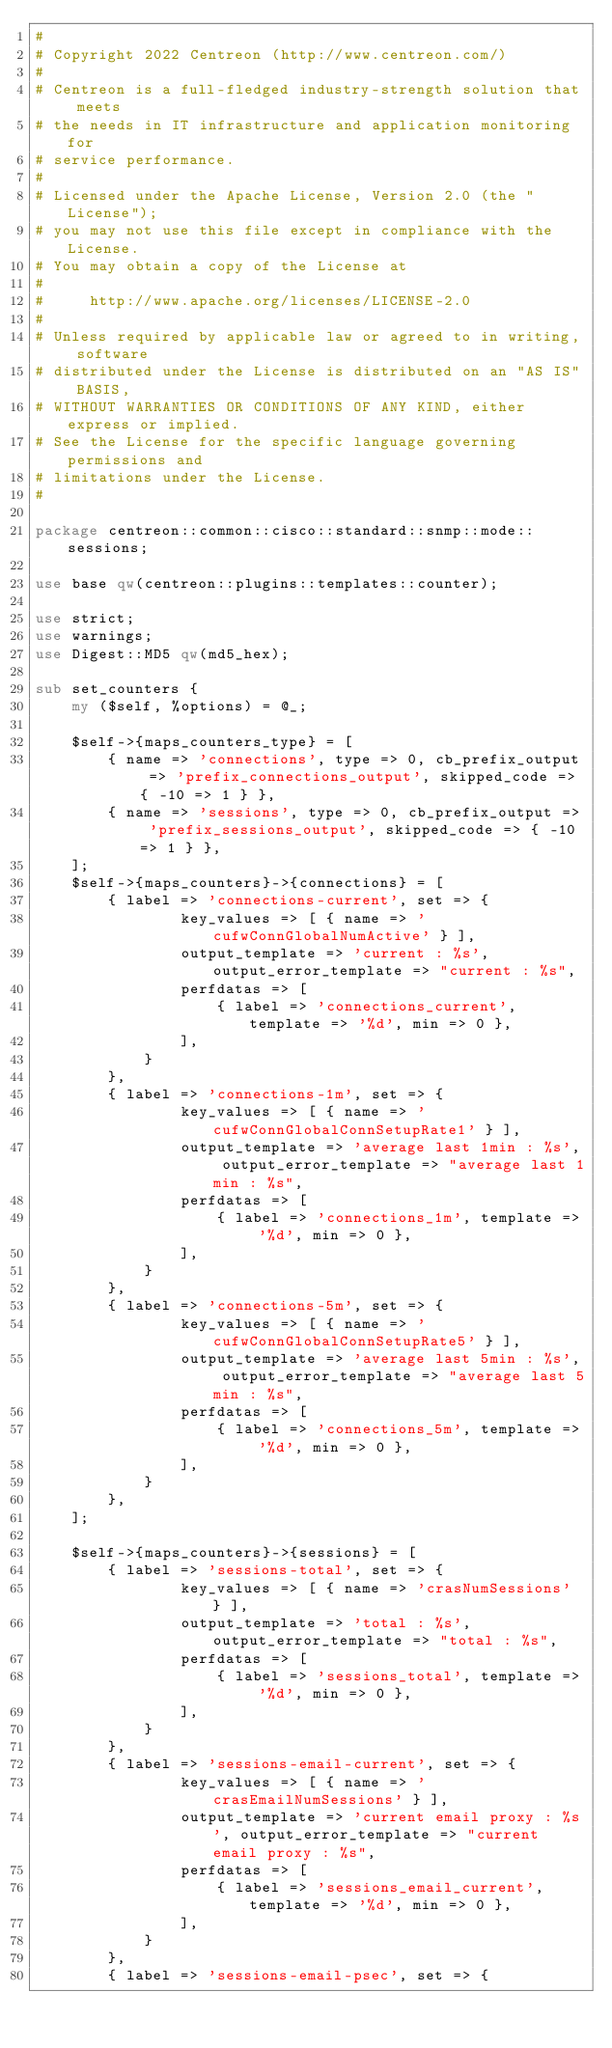Convert code to text. <code><loc_0><loc_0><loc_500><loc_500><_Perl_>#
# Copyright 2022 Centreon (http://www.centreon.com/)
#
# Centreon is a full-fledged industry-strength solution that meets
# the needs in IT infrastructure and application monitoring for
# service performance.
#
# Licensed under the Apache License, Version 2.0 (the "License");
# you may not use this file except in compliance with the License.
# You may obtain a copy of the License at
#
#     http://www.apache.org/licenses/LICENSE-2.0
#
# Unless required by applicable law or agreed to in writing, software
# distributed under the License is distributed on an "AS IS" BASIS,
# WITHOUT WARRANTIES OR CONDITIONS OF ANY KIND, either express or implied.
# See the License for the specific language governing permissions and
# limitations under the License.
#

package centreon::common::cisco::standard::snmp::mode::sessions;

use base qw(centreon::plugins::templates::counter);

use strict;
use warnings;
use Digest::MD5 qw(md5_hex);

sub set_counters {
    my ($self, %options) = @_;
    
    $self->{maps_counters_type} = [
        { name => 'connections', type => 0, cb_prefix_output => 'prefix_connections_output', skipped_code => { -10 => 1 } },
        { name => 'sessions', type => 0, cb_prefix_output => 'prefix_sessions_output', skipped_code => { -10 => 1 } },
    ];
    $self->{maps_counters}->{connections} = [
        { label => 'connections-current', set => {
                key_values => [ { name => 'cufwConnGlobalNumActive' } ],
                output_template => 'current : %s', output_error_template => "current : %s",
                perfdatas => [
                    { label => 'connections_current', template => '%d', min => 0 },
                ],
            }
        },
        { label => 'connections-1m', set => {
                key_values => [ { name => 'cufwConnGlobalConnSetupRate1' } ],
                output_template => 'average last 1min : %s', output_error_template => "average last 1min : %s",
                perfdatas => [
                    { label => 'connections_1m', template => '%d', min => 0 },
                ],
            }
        },
        { label => 'connections-5m', set => {
                key_values => [ { name => 'cufwConnGlobalConnSetupRate5' } ],
                output_template => 'average last 5min : %s', output_error_template => "average last 5min : %s",
                perfdatas => [
                    { label => 'connections_5m', template => '%d', min => 0 },
                ],
            }
        },
    ];

    $self->{maps_counters}->{sessions} = [
        { label => 'sessions-total', set => {
                key_values => [ { name => 'crasNumSessions' } ],
                output_template => 'total : %s', output_error_template => "total : %s",
                perfdatas => [
                    { label => 'sessions_total', template => '%d', min => 0 },
                ],
            }
        },
        { label => 'sessions-email-current', set => {
                key_values => [ { name => 'crasEmailNumSessions' } ],
                output_template => 'current email proxy : %s', output_error_template => "current email proxy : %s",
                perfdatas => [
                    { label => 'sessions_email_current', template => '%d', min => 0 },
                ],
            }
        },
        { label => 'sessions-email-psec', set => {</code> 